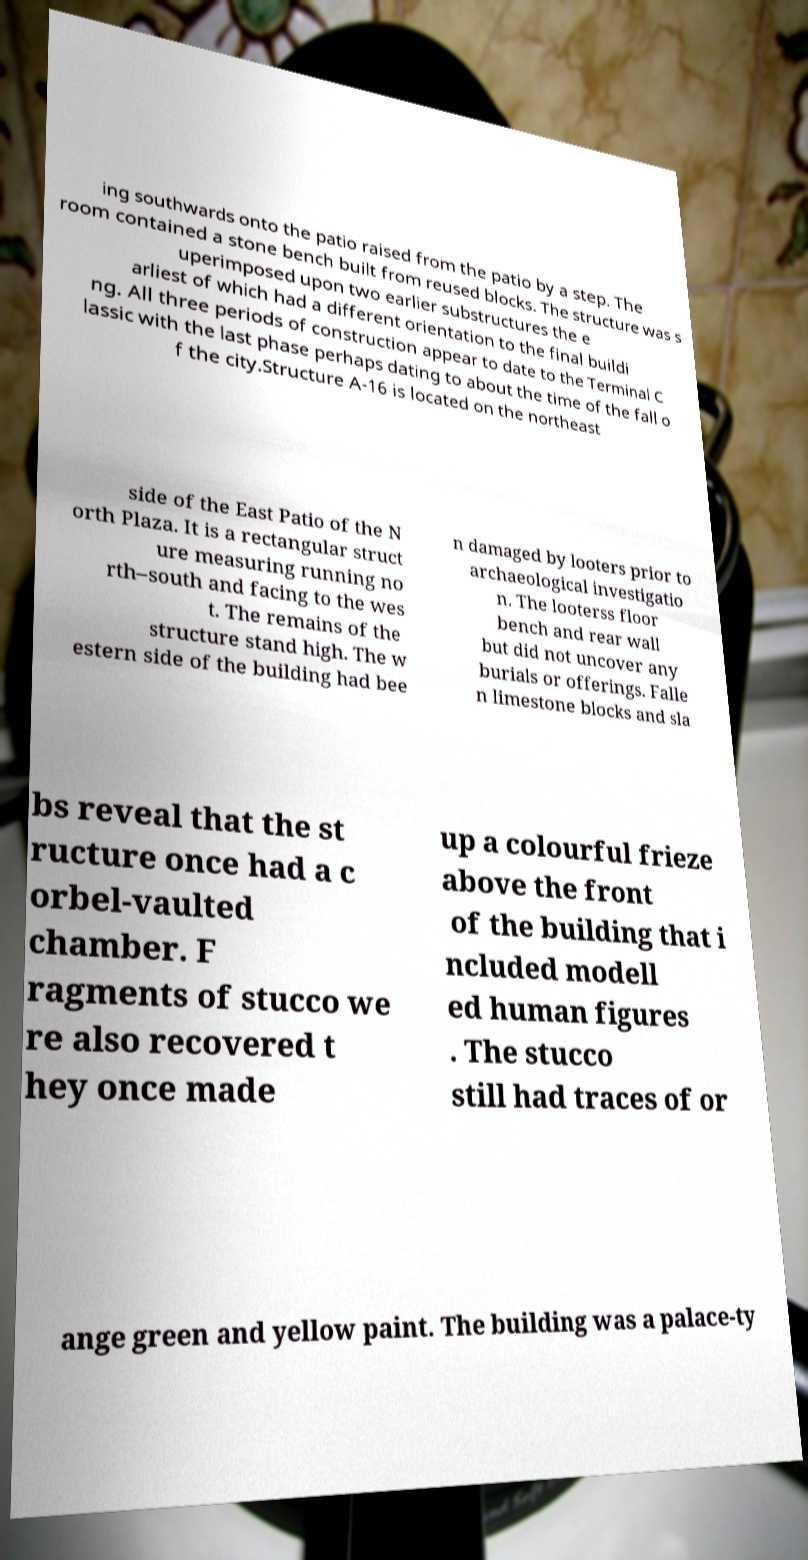Can you read and provide the text displayed in the image?This photo seems to have some interesting text. Can you extract and type it out for me? ing southwards onto the patio raised from the patio by a step. The room contained a stone bench built from reused blocks. The structure was s uperimposed upon two earlier substructures the e arliest of which had a different orientation to the final buildi ng. All three periods of construction appear to date to the Terminal C lassic with the last phase perhaps dating to about the time of the fall o f the city.Structure A-16 is located on the northeast side of the East Patio of the N orth Plaza. It is a rectangular struct ure measuring running no rth–south and facing to the wes t. The remains of the structure stand high. The w estern side of the building had bee n damaged by looters prior to archaeological investigatio n. The looterss floor bench and rear wall but did not uncover any burials or offerings. Falle n limestone blocks and sla bs reveal that the st ructure once had a c orbel-vaulted chamber. F ragments of stucco we re also recovered t hey once made up a colourful frieze above the front of the building that i ncluded modell ed human figures . The stucco still had traces of or ange green and yellow paint. The building was a palace-ty 